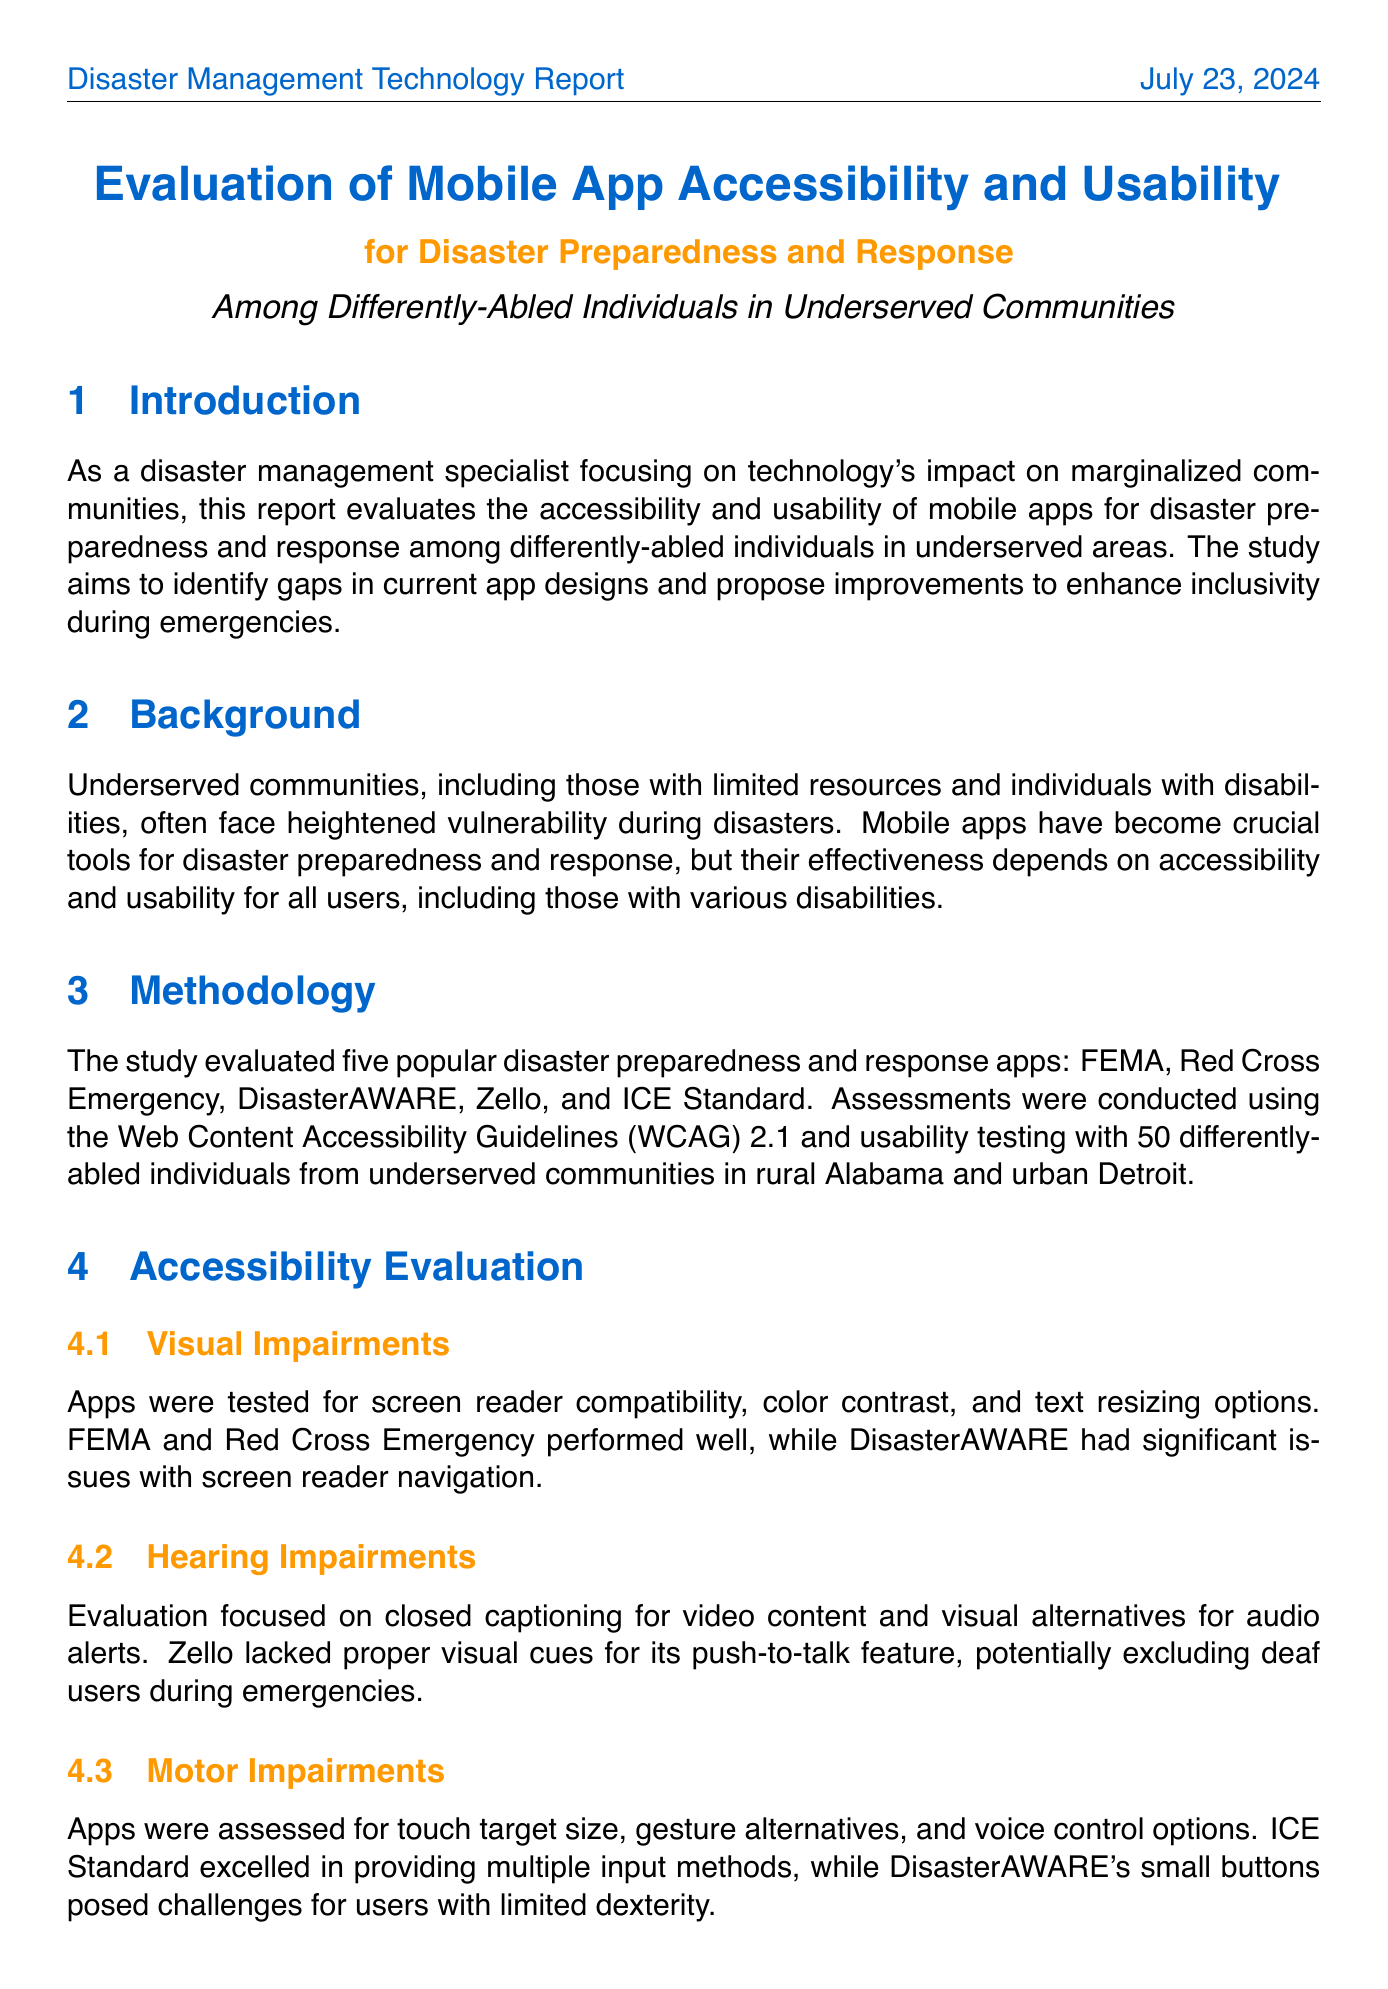what is the primary focus of the report? The report evaluates the accessibility and usability of mobile apps for disaster preparedness and response among differently-abled individuals in underserved areas.
Answer: accessibility and usability of mobile apps how many apps were evaluated in the study? The study evaluated five popular disaster preparedness and response apps.
Answer: five which app had significant issues with screen reader navigation? The app that had significant issues with screen reader navigation was DisasterAWARE.
Answer: DisasterAWARE what percentage of participants reported difficulty using at least one evaluated app? 72% of participants reported difficulty using at least one of the evaluated apps due to accessibility issues.
Answer: 72% which community faced more heightened vulnerability during disasters? Underserved communities, including those with limited resources and individuals with disabilities, often face heightened vulnerability during disasters.
Answer: underserved communities what is the recommendation for improving disaster-related apps? One recommendation is implementing universal design principles in all disaster-related apps.
Answer: universal design principles which app excels in providing multiple input methods? The app that excelled in providing multiple input methods is ICE Standard.
Answer: ICE Standard who quoted the potential of mobile apps for marginalized communities? Dr. Aisha Johnson quoted the potential of mobile apps for marginalized communities.
Answer: Dr. Aisha Johnson 